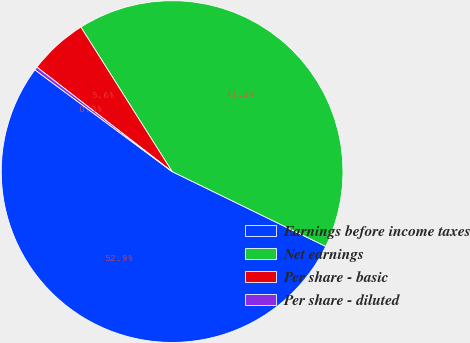Convert chart. <chart><loc_0><loc_0><loc_500><loc_500><pie_chart><fcel>Earnings before income taxes<fcel>Net earnings<fcel>Per share - basic<fcel>Per share - diluted<nl><fcel>52.94%<fcel>41.18%<fcel>5.57%<fcel>0.31%<nl></chart> 